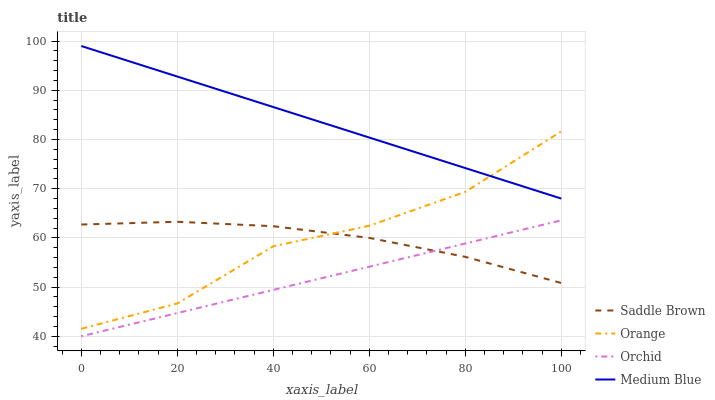Does Orchid have the minimum area under the curve?
Answer yes or no. Yes. Does Medium Blue have the maximum area under the curve?
Answer yes or no. Yes. Does Saddle Brown have the minimum area under the curve?
Answer yes or no. No. Does Saddle Brown have the maximum area under the curve?
Answer yes or no. No. Is Orchid the smoothest?
Answer yes or no. Yes. Is Orange the roughest?
Answer yes or no. Yes. Is Medium Blue the smoothest?
Answer yes or no. No. Is Medium Blue the roughest?
Answer yes or no. No. Does Saddle Brown have the lowest value?
Answer yes or no. No. Does Medium Blue have the highest value?
Answer yes or no. Yes. Does Saddle Brown have the highest value?
Answer yes or no. No. Is Saddle Brown less than Medium Blue?
Answer yes or no. Yes. Is Medium Blue greater than Saddle Brown?
Answer yes or no. Yes. Does Orchid intersect Saddle Brown?
Answer yes or no. Yes. Is Orchid less than Saddle Brown?
Answer yes or no. No. Is Orchid greater than Saddle Brown?
Answer yes or no. No. Does Saddle Brown intersect Medium Blue?
Answer yes or no. No. 